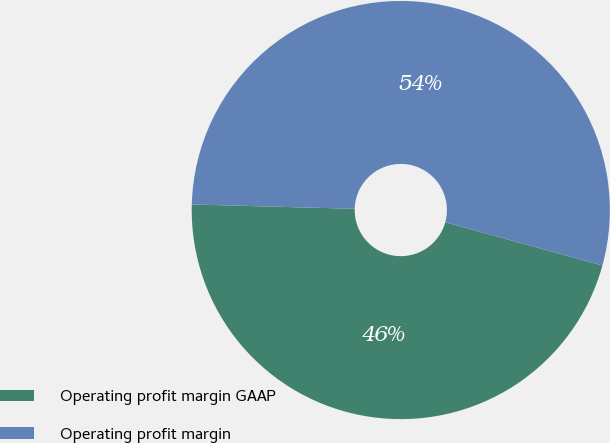Convert chart to OTSL. <chart><loc_0><loc_0><loc_500><loc_500><pie_chart><fcel>Operating profit margin GAAP<fcel>Operating profit margin<nl><fcel>46.15%<fcel>53.85%<nl></chart> 